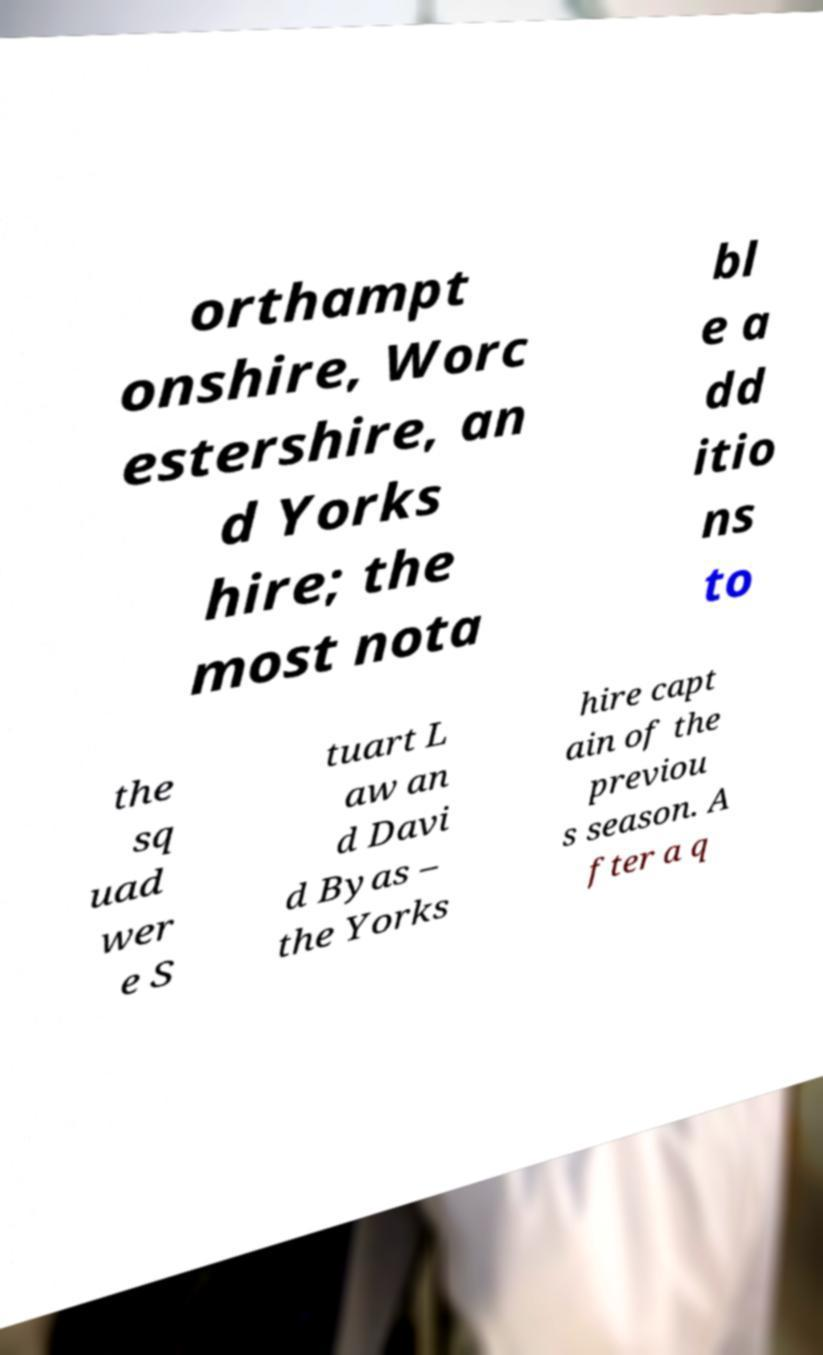Can you read and provide the text displayed in the image?This photo seems to have some interesting text. Can you extract and type it out for me? orthampt onshire, Worc estershire, an d Yorks hire; the most nota bl e a dd itio ns to the sq uad wer e S tuart L aw an d Davi d Byas – the Yorks hire capt ain of the previou s season. A fter a q 